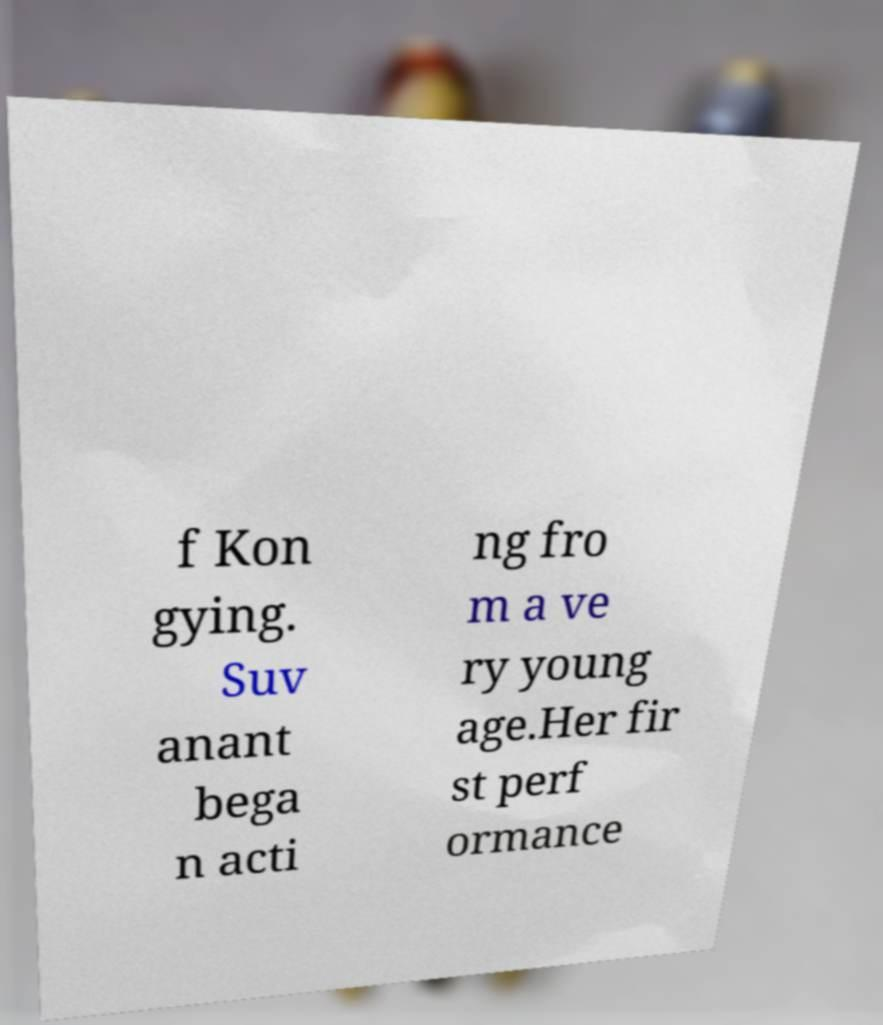Please read and relay the text visible in this image. What does it say? f Kon gying. Suv anant bega n acti ng fro m a ve ry young age.Her fir st perf ormance 